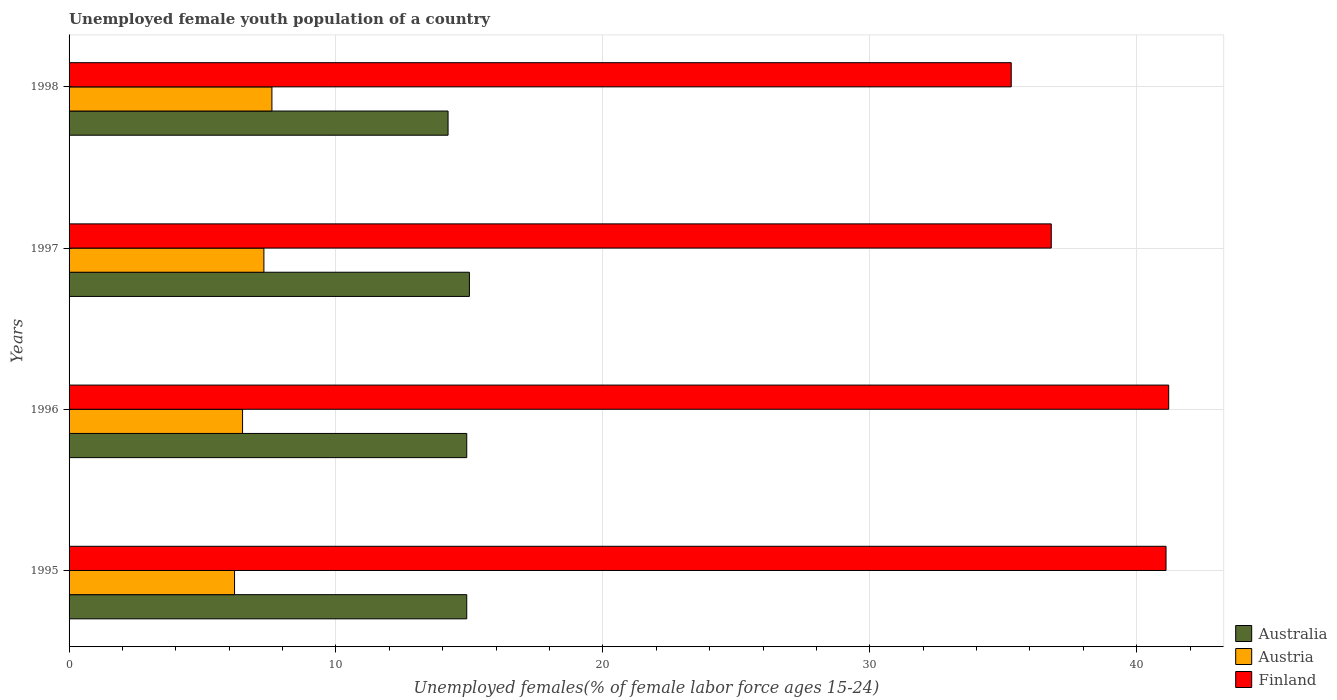How many different coloured bars are there?
Ensure brevity in your answer.  3. How many groups of bars are there?
Give a very brief answer. 4. Are the number of bars on each tick of the Y-axis equal?
Keep it short and to the point. Yes. How many bars are there on the 2nd tick from the bottom?
Make the answer very short. 3. What is the label of the 1st group of bars from the top?
Provide a short and direct response. 1998. In how many cases, is the number of bars for a given year not equal to the number of legend labels?
Provide a short and direct response. 0. What is the percentage of unemployed female youth population in Austria in 1995?
Keep it short and to the point. 6.2. Across all years, what is the minimum percentage of unemployed female youth population in Austria?
Offer a terse response. 6.2. In which year was the percentage of unemployed female youth population in Australia maximum?
Make the answer very short. 1997. What is the total percentage of unemployed female youth population in Australia in the graph?
Make the answer very short. 59. What is the difference between the percentage of unemployed female youth population in Australia in 1997 and that in 1998?
Offer a very short reply. 0.8. What is the difference between the percentage of unemployed female youth population in Finland in 1998 and the percentage of unemployed female youth population in Austria in 1995?
Ensure brevity in your answer.  29.1. What is the average percentage of unemployed female youth population in Finland per year?
Your answer should be compact. 38.6. In the year 1997, what is the difference between the percentage of unemployed female youth population in Australia and percentage of unemployed female youth population in Finland?
Your answer should be compact. -21.8. In how many years, is the percentage of unemployed female youth population in Austria greater than 26 %?
Provide a succinct answer. 0. What is the ratio of the percentage of unemployed female youth population in Australia in 1995 to that in 1997?
Offer a terse response. 0.99. Is the difference between the percentage of unemployed female youth population in Australia in 1997 and 1998 greater than the difference between the percentage of unemployed female youth population in Finland in 1997 and 1998?
Offer a terse response. No. What is the difference between the highest and the second highest percentage of unemployed female youth population in Finland?
Your response must be concise. 0.1. What is the difference between the highest and the lowest percentage of unemployed female youth population in Australia?
Give a very brief answer. 0.8. Is the sum of the percentage of unemployed female youth population in Austria in 1996 and 1998 greater than the maximum percentage of unemployed female youth population in Australia across all years?
Keep it short and to the point. No. What does the 1st bar from the top in 1996 represents?
Offer a terse response. Finland. What does the 1st bar from the bottom in 1995 represents?
Provide a short and direct response. Australia. Is it the case that in every year, the sum of the percentage of unemployed female youth population in Austria and percentage of unemployed female youth population in Finland is greater than the percentage of unemployed female youth population in Australia?
Offer a very short reply. Yes. How many bars are there?
Give a very brief answer. 12. Are all the bars in the graph horizontal?
Offer a terse response. Yes. How many years are there in the graph?
Give a very brief answer. 4. Are the values on the major ticks of X-axis written in scientific E-notation?
Your answer should be very brief. No. Where does the legend appear in the graph?
Keep it short and to the point. Bottom right. How are the legend labels stacked?
Give a very brief answer. Vertical. What is the title of the graph?
Provide a succinct answer. Unemployed female youth population of a country. What is the label or title of the X-axis?
Your response must be concise. Unemployed females(% of female labor force ages 15-24). What is the Unemployed females(% of female labor force ages 15-24) of Australia in 1995?
Keep it short and to the point. 14.9. What is the Unemployed females(% of female labor force ages 15-24) in Austria in 1995?
Offer a terse response. 6.2. What is the Unemployed females(% of female labor force ages 15-24) of Finland in 1995?
Offer a very short reply. 41.1. What is the Unemployed females(% of female labor force ages 15-24) of Australia in 1996?
Ensure brevity in your answer.  14.9. What is the Unemployed females(% of female labor force ages 15-24) in Finland in 1996?
Provide a short and direct response. 41.2. What is the Unemployed females(% of female labor force ages 15-24) in Australia in 1997?
Provide a short and direct response. 15. What is the Unemployed females(% of female labor force ages 15-24) in Austria in 1997?
Provide a succinct answer. 7.3. What is the Unemployed females(% of female labor force ages 15-24) of Finland in 1997?
Offer a very short reply. 36.8. What is the Unemployed females(% of female labor force ages 15-24) in Australia in 1998?
Your response must be concise. 14.2. What is the Unemployed females(% of female labor force ages 15-24) of Austria in 1998?
Keep it short and to the point. 7.6. What is the Unemployed females(% of female labor force ages 15-24) of Finland in 1998?
Keep it short and to the point. 35.3. Across all years, what is the maximum Unemployed females(% of female labor force ages 15-24) in Australia?
Your answer should be very brief. 15. Across all years, what is the maximum Unemployed females(% of female labor force ages 15-24) of Austria?
Provide a succinct answer. 7.6. Across all years, what is the maximum Unemployed females(% of female labor force ages 15-24) of Finland?
Your answer should be compact. 41.2. Across all years, what is the minimum Unemployed females(% of female labor force ages 15-24) in Australia?
Keep it short and to the point. 14.2. Across all years, what is the minimum Unemployed females(% of female labor force ages 15-24) in Austria?
Make the answer very short. 6.2. Across all years, what is the minimum Unemployed females(% of female labor force ages 15-24) in Finland?
Your answer should be very brief. 35.3. What is the total Unemployed females(% of female labor force ages 15-24) in Australia in the graph?
Your answer should be compact. 59. What is the total Unemployed females(% of female labor force ages 15-24) of Austria in the graph?
Offer a very short reply. 27.6. What is the total Unemployed females(% of female labor force ages 15-24) in Finland in the graph?
Make the answer very short. 154.4. What is the difference between the Unemployed females(% of female labor force ages 15-24) in Australia in 1995 and that in 1996?
Your answer should be compact. 0. What is the difference between the Unemployed females(% of female labor force ages 15-24) in Austria in 1995 and that in 1996?
Your response must be concise. -0.3. What is the difference between the Unemployed females(% of female labor force ages 15-24) in Austria in 1995 and that in 1998?
Offer a very short reply. -1.4. What is the difference between the Unemployed females(% of female labor force ages 15-24) in Australia in 1996 and that in 1997?
Your answer should be very brief. -0.1. What is the difference between the Unemployed females(% of female labor force ages 15-24) of Austria in 1996 and that in 1997?
Give a very brief answer. -0.8. What is the difference between the Unemployed females(% of female labor force ages 15-24) of Finland in 1996 and that in 1997?
Make the answer very short. 4.4. What is the difference between the Unemployed females(% of female labor force ages 15-24) of Australia in 1996 and that in 1998?
Offer a terse response. 0.7. What is the difference between the Unemployed females(% of female labor force ages 15-24) in Austria in 1996 and that in 1998?
Provide a succinct answer. -1.1. What is the difference between the Unemployed females(% of female labor force ages 15-24) in Australia in 1997 and that in 1998?
Offer a terse response. 0.8. What is the difference between the Unemployed females(% of female labor force ages 15-24) of Australia in 1995 and the Unemployed females(% of female labor force ages 15-24) of Finland in 1996?
Your answer should be very brief. -26.3. What is the difference between the Unemployed females(% of female labor force ages 15-24) in Austria in 1995 and the Unemployed females(% of female labor force ages 15-24) in Finland in 1996?
Your answer should be very brief. -35. What is the difference between the Unemployed females(% of female labor force ages 15-24) of Australia in 1995 and the Unemployed females(% of female labor force ages 15-24) of Austria in 1997?
Offer a very short reply. 7.6. What is the difference between the Unemployed females(% of female labor force ages 15-24) in Australia in 1995 and the Unemployed females(% of female labor force ages 15-24) in Finland in 1997?
Ensure brevity in your answer.  -21.9. What is the difference between the Unemployed females(% of female labor force ages 15-24) of Austria in 1995 and the Unemployed females(% of female labor force ages 15-24) of Finland in 1997?
Ensure brevity in your answer.  -30.6. What is the difference between the Unemployed females(% of female labor force ages 15-24) in Australia in 1995 and the Unemployed females(% of female labor force ages 15-24) in Austria in 1998?
Ensure brevity in your answer.  7.3. What is the difference between the Unemployed females(% of female labor force ages 15-24) of Australia in 1995 and the Unemployed females(% of female labor force ages 15-24) of Finland in 1998?
Offer a terse response. -20.4. What is the difference between the Unemployed females(% of female labor force ages 15-24) in Austria in 1995 and the Unemployed females(% of female labor force ages 15-24) in Finland in 1998?
Make the answer very short. -29.1. What is the difference between the Unemployed females(% of female labor force ages 15-24) of Australia in 1996 and the Unemployed females(% of female labor force ages 15-24) of Finland in 1997?
Provide a short and direct response. -21.9. What is the difference between the Unemployed females(% of female labor force ages 15-24) in Austria in 1996 and the Unemployed females(% of female labor force ages 15-24) in Finland in 1997?
Offer a terse response. -30.3. What is the difference between the Unemployed females(% of female labor force ages 15-24) in Australia in 1996 and the Unemployed females(% of female labor force ages 15-24) in Austria in 1998?
Provide a short and direct response. 7.3. What is the difference between the Unemployed females(% of female labor force ages 15-24) in Australia in 1996 and the Unemployed females(% of female labor force ages 15-24) in Finland in 1998?
Ensure brevity in your answer.  -20.4. What is the difference between the Unemployed females(% of female labor force ages 15-24) in Austria in 1996 and the Unemployed females(% of female labor force ages 15-24) in Finland in 1998?
Make the answer very short. -28.8. What is the difference between the Unemployed females(% of female labor force ages 15-24) of Australia in 1997 and the Unemployed females(% of female labor force ages 15-24) of Finland in 1998?
Provide a short and direct response. -20.3. What is the average Unemployed females(% of female labor force ages 15-24) of Australia per year?
Keep it short and to the point. 14.75. What is the average Unemployed females(% of female labor force ages 15-24) in Austria per year?
Your answer should be very brief. 6.9. What is the average Unemployed females(% of female labor force ages 15-24) in Finland per year?
Give a very brief answer. 38.6. In the year 1995, what is the difference between the Unemployed females(% of female labor force ages 15-24) of Australia and Unemployed females(% of female labor force ages 15-24) of Austria?
Make the answer very short. 8.7. In the year 1995, what is the difference between the Unemployed females(% of female labor force ages 15-24) of Australia and Unemployed females(% of female labor force ages 15-24) of Finland?
Your response must be concise. -26.2. In the year 1995, what is the difference between the Unemployed females(% of female labor force ages 15-24) in Austria and Unemployed females(% of female labor force ages 15-24) in Finland?
Keep it short and to the point. -34.9. In the year 1996, what is the difference between the Unemployed females(% of female labor force ages 15-24) of Australia and Unemployed females(% of female labor force ages 15-24) of Finland?
Your answer should be compact. -26.3. In the year 1996, what is the difference between the Unemployed females(% of female labor force ages 15-24) of Austria and Unemployed females(% of female labor force ages 15-24) of Finland?
Offer a terse response. -34.7. In the year 1997, what is the difference between the Unemployed females(% of female labor force ages 15-24) in Australia and Unemployed females(% of female labor force ages 15-24) in Austria?
Give a very brief answer. 7.7. In the year 1997, what is the difference between the Unemployed females(% of female labor force ages 15-24) in Australia and Unemployed females(% of female labor force ages 15-24) in Finland?
Your answer should be compact. -21.8. In the year 1997, what is the difference between the Unemployed females(% of female labor force ages 15-24) of Austria and Unemployed females(% of female labor force ages 15-24) of Finland?
Offer a terse response. -29.5. In the year 1998, what is the difference between the Unemployed females(% of female labor force ages 15-24) of Australia and Unemployed females(% of female labor force ages 15-24) of Finland?
Make the answer very short. -21.1. In the year 1998, what is the difference between the Unemployed females(% of female labor force ages 15-24) in Austria and Unemployed females(% of female labor force ages 15-24) in Finland?
Give a very brief answer. -27.7. What is the ratio of the Unemployed females(% of female labor force ages 15-24) in Australia in 1995 to that in 1996?
Your response must be concise. 1. What is the ratio of the Unemployed females(% of female labor force ages 15-24) of Austria in 1995 to that in 1996?
Your response must be concise. 0.95. What is the ratio of the Unemployed females(% of female labor force ages 15-24) in Austria in 1995 to that in 1997?
Make the answer very short. 0.85. What is the ratio of the Unemployed females(% of female labor force ages 15-24) of Finland in 1995 to that in 1997?
Offer a terse response. 1.12. What is the ratio of the Unemployed females(% of female labor force ages 15-24) of Australia in 1995 to that in 1998?
Offer a terse response. 1.05. What is the ratio of the Unemployed females(% of female labor force ages 15-24) in Austria in 1995 to that in 1998?
Provide a succinct answer. 0.82. What is the ratio of the Unemployed females(% of female labor force ages 15-24) of Finland in 1995 to that in 1998?
Ensure brevity in your answer.  1.16. What is the ratio of the Unemployed females(% of female labor force ages 15-24) in Australia in 1996 to that in 1997?
Give a very brief answer. 0.99. What is the ratio of the Unemployed females(% of female labor force ages 15-24) of Austria in 1996 to that in 1997?
Your answer should be very brief. 0.89. What is the ratio of the Unemployed females(% of female labor force ages 15-24) in Finland in 1996 to that in 1997?
Your answer should be compact. 1.12. What is the ratio of the Unemployed females(% of female labor force ages 15-24) in Australia in 1996 to that in 1998?
Ensure brevity in your answer.  1.05. What is the ratio of the Unemployed females(% of female labor force ages 15-24) of Austria in 1996 to that in 1998?
Provide a short and direct response. 0.86. What is the ratio of the Unemployed females(% of female labor force ages 15-24) of Finland in 1996 to that in 1998?
Your response must be concise. 1.17. What is the ratio of the Unemployed females(% of female labor force ages 15-24) in Australia in 1997 to that in 1998?
Offer a very short reply. 1.06. What is the ratio of the Unemployed females(% of female labor force ages 15-24) of Austria in 1997 to that in 1998?
Make the answer very short. 0.96. What is the ratio of the Unemployed females(% of female labor force ages 15-24) of Finland in 1997 to that in 1998?
Provide a short and direct response. 1.04. What is the difference between the highest and the second highest Unemployed females(% of female labor force ages 15-24) in Australia?
Provide a short and direct response. 0.1. What is the difference between the highest and the lowest Unemployed females(% of female labor force ages 15-24) of Australia?
Give a very brief answer. 0.8. What is the difference between the highest and the lowest Unemployed females(% of female labor force ages 15-24) in Austria?
Offer a very short reply. 1.4. 